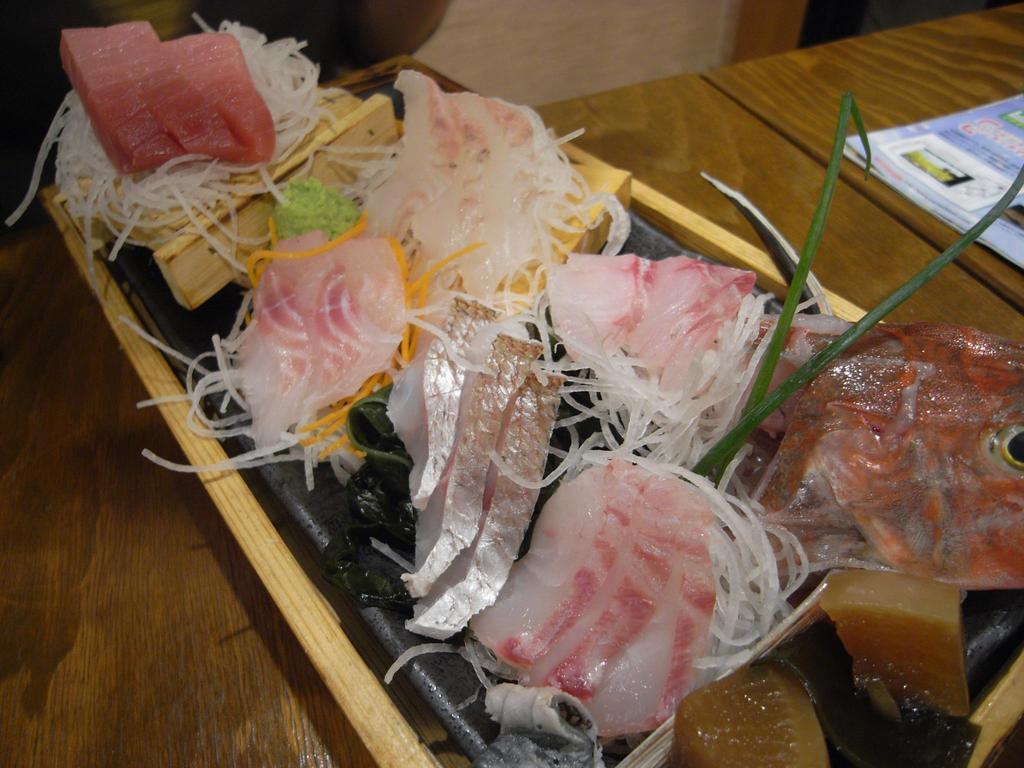Please provide a concise description of this image. In this picture we can see some food items on the black plate and the plate is on a tray and the tray is on the wooden table. On the table, it looks like a book. 